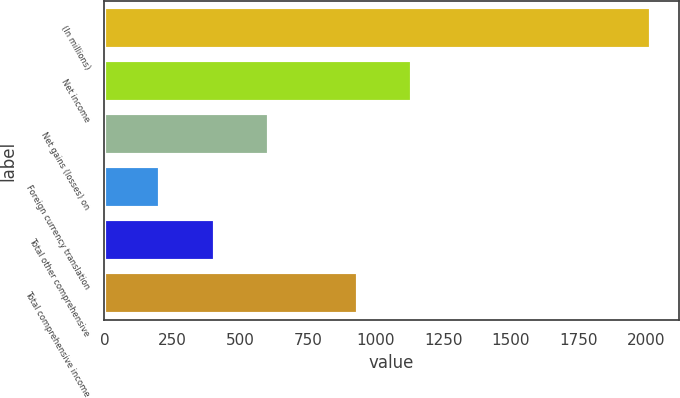Convert chart. <chart><loc_0><loc_0><loc_500><loc_500><bar_chart><fcel>(In millions)<fcel>Net income<fcel>Net gains (losses) on<fcel>Foreign currency translation<fcel>Total other comprehensive<fcel>Total comprehensive income<nl><fcel>2018<fcel>1136.3<fcel>608.9<fcel>206.3<fcel>407.6<fcel>935<nl></chart> 